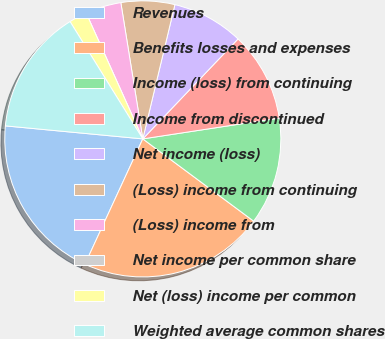Convert chart to OTSL. <chart><loc_0><loc_0><loc_500><loc_500><pie_chart><fcel>Revenues<fcel>Benefits losses and expenses<fcel>Income (loss) from continuing<fcel>Income from discontinued<fcel>Net income (loss)<fcel>(Loss) income from continuing<fcel>(Loss) income from<fcel>Net income per common share<fcel>Net (loss) income per common<fcel>Weighted average common shares<nl><fcel>19.62%<fcel>21.72%<fcel>12.57%<fcel>10.47%<fcel>8.38%<fcel>6.28%<fcel>4.19%<fcel>0.0%<fcel>2.1%<fcel>14.66%<nl></chart> 